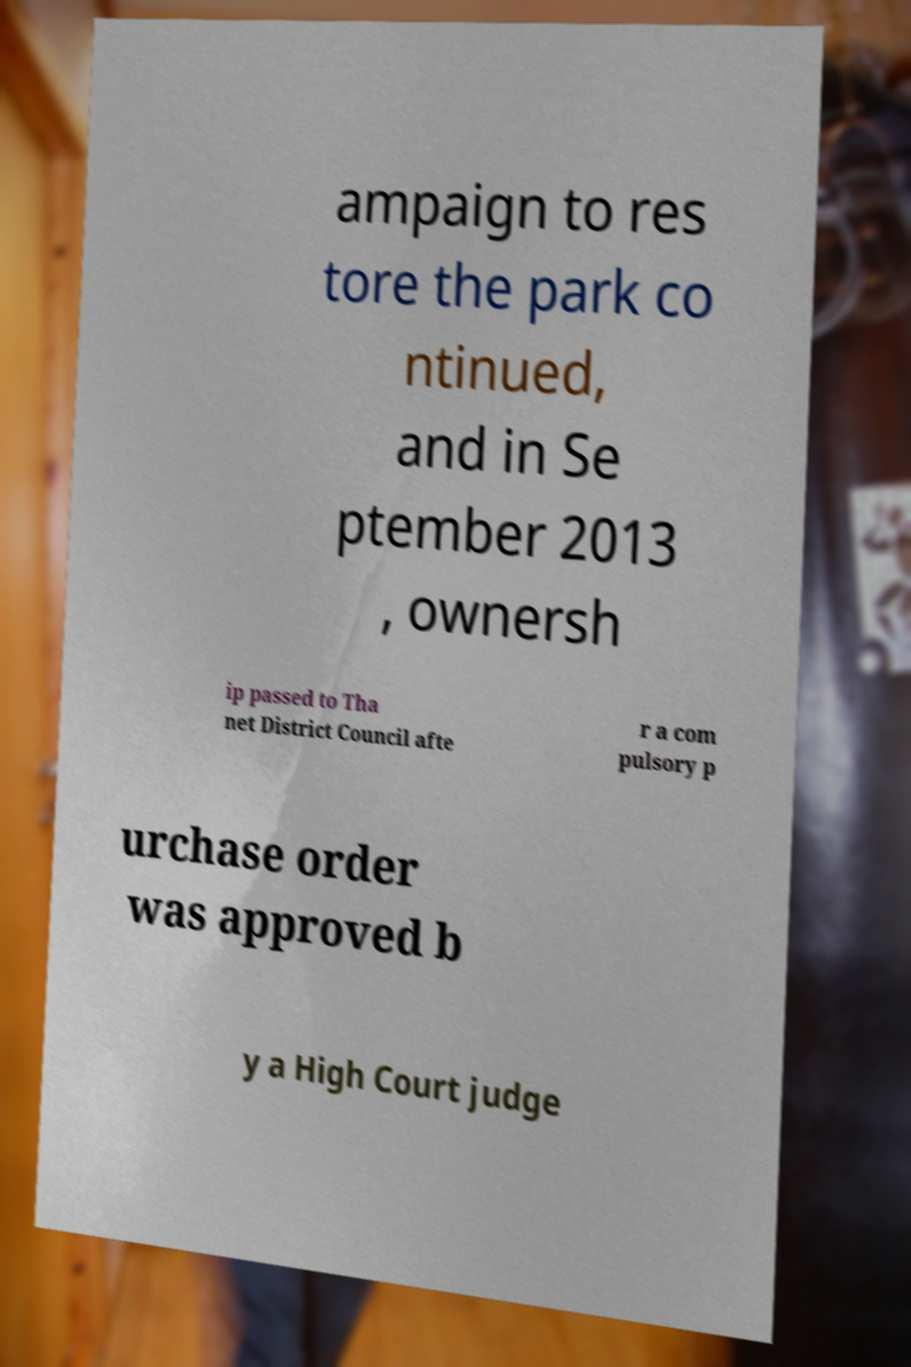Can you accurately transcribe the text from the provided image for me? ampaign to res tore the park co ntinued, and in Se ptember 2013 , ownersh ip passed to Tha net District Council afte r a com pulsory p urchase order was approved b y a High Court judge 